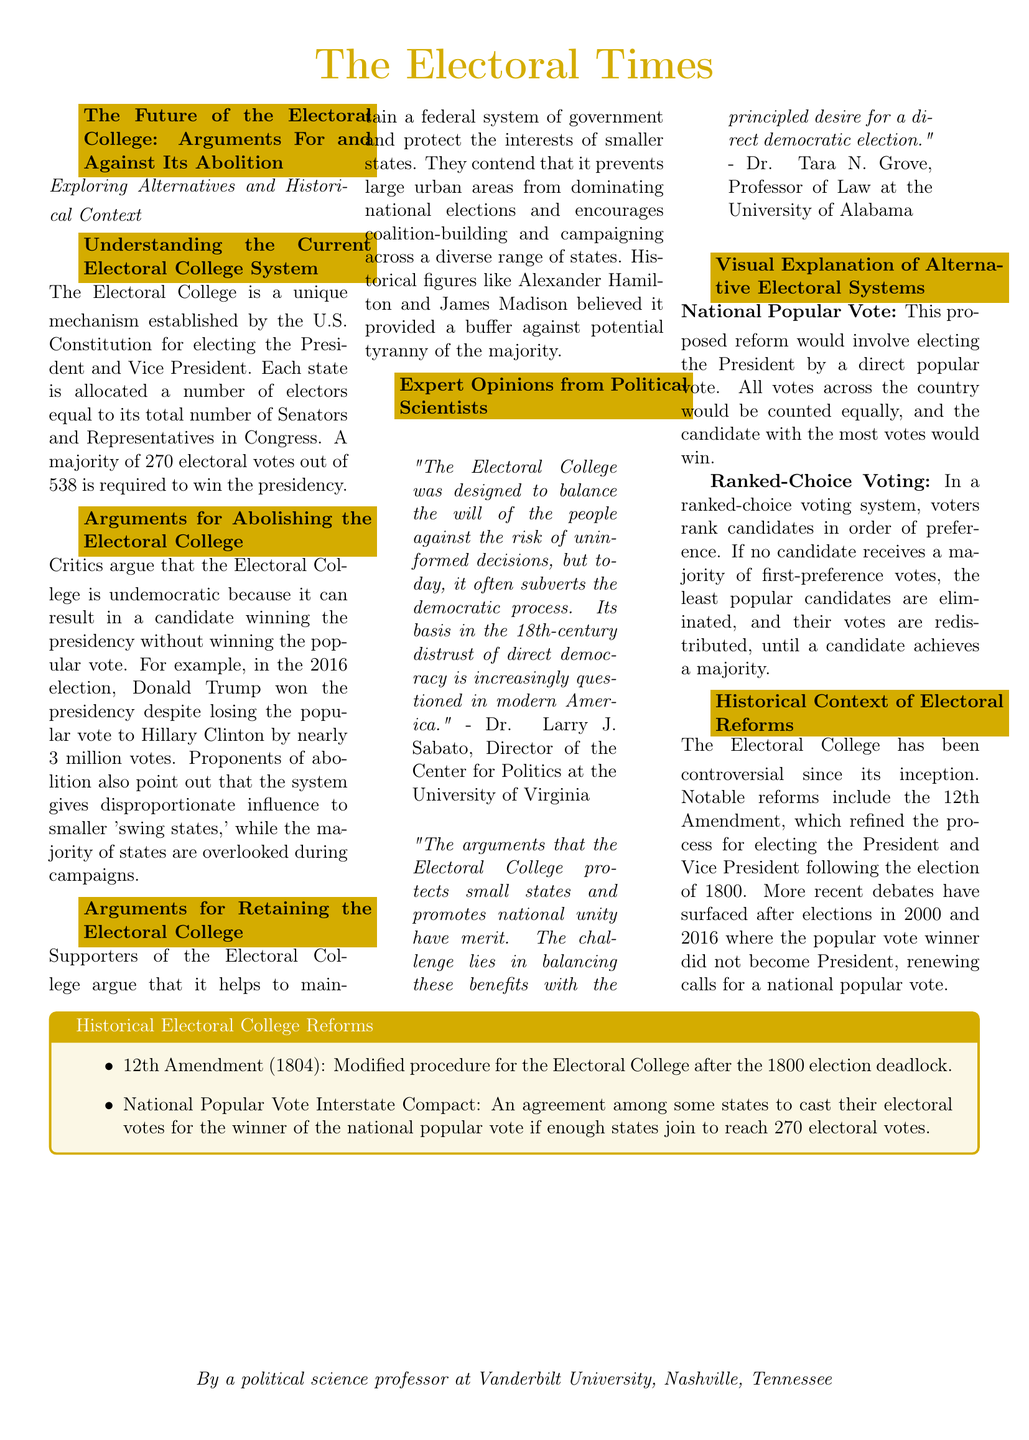What is required to win the presidency? The document states that a majority of 270 electoral votes out of 538 is required to win the presidency.
Answer: 270 Who won the popular vote in the 2016 election? The document mentions that Hillary Clinton lost the presidency despite winning the popular vote.
Answer: Hillary Clinton What alternative electoral system involves ranking candidates? The document describes ranked-choice voting as a system where voters rank candidates in order of preference.
Answer: Ranked-Choice Voting Which historical figure believed the Electoral College prevents tyranny of the majority? The document references historical figures who supported the Electoral College, including Alexander Hamilton and James Madison.
Answer: Alexander Hamilton What reform modified the procedure for the Electoral College in 1804? The document names the 12th Amendment as the reform that modified the Electoral College procedure.
Answer: 12th Amendment According to Dr. Larry J. Sabato, what modern risk does the Electoral College pose? Dr. Larry J. Sabato argues that the Electoral College subverts the democratic process in modern America.
Answer: Subverts democracy What does the National Popular Vote propose? The document outlines that the National Popular Vote would involve electing the President by a direct popular vote.
Answer: Direct popular vote What state compact aims for electors to vote in accordance with the national popular vote? The document mentions the National Popular Vote Interstate Compact as the agreement among states.
Answer: National Popular Vote Interstate Compact 